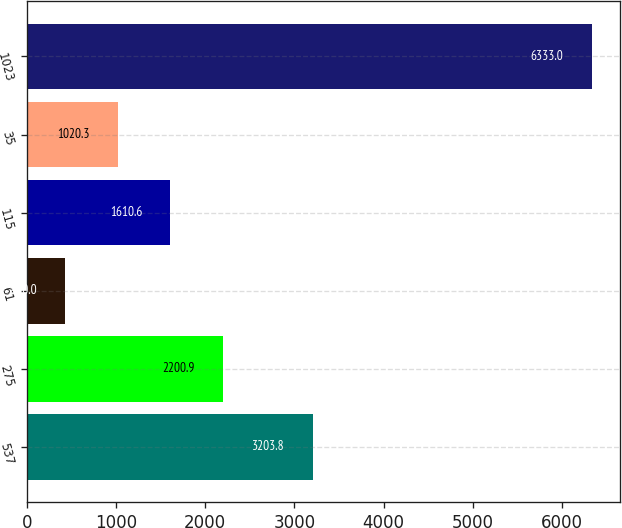Convert chart. <chart><loc_0><loc_0><loc_500><loc_500><bar_chart><fcel>537<fcel>275<fcel>61<fcel>115<fcel>35<fcel>1023<nl><fcel>3203.8<fcel>2200.9<fcel>430<fcel>1610.6<fcel>1020.3<fcel>6333<nl></chart> 